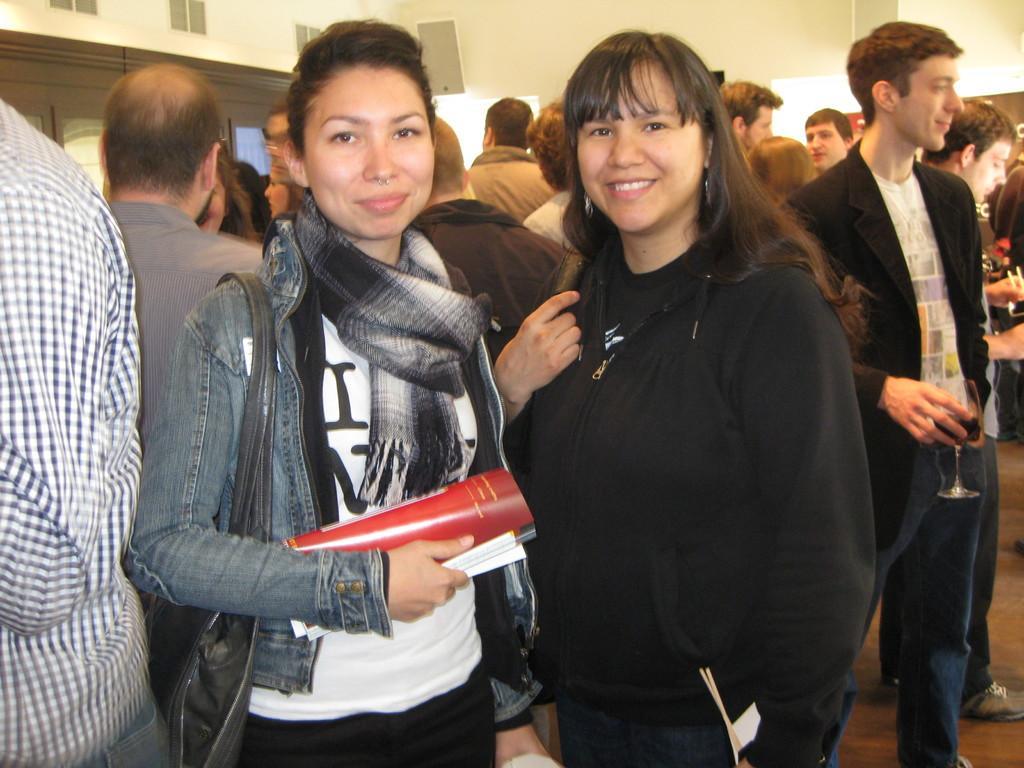Describe this image in one or two sentences. In front of the image on the left side there is a lady with stole around her neck and she wore a bag. She is holding a book in her hand and she is smiling. Beside her on the right there is a lady smiling. Behind them there are few people standing. On the right corner of the image there are few men holding glasses in their hands. Behind them in the background there is a wall with windows. 